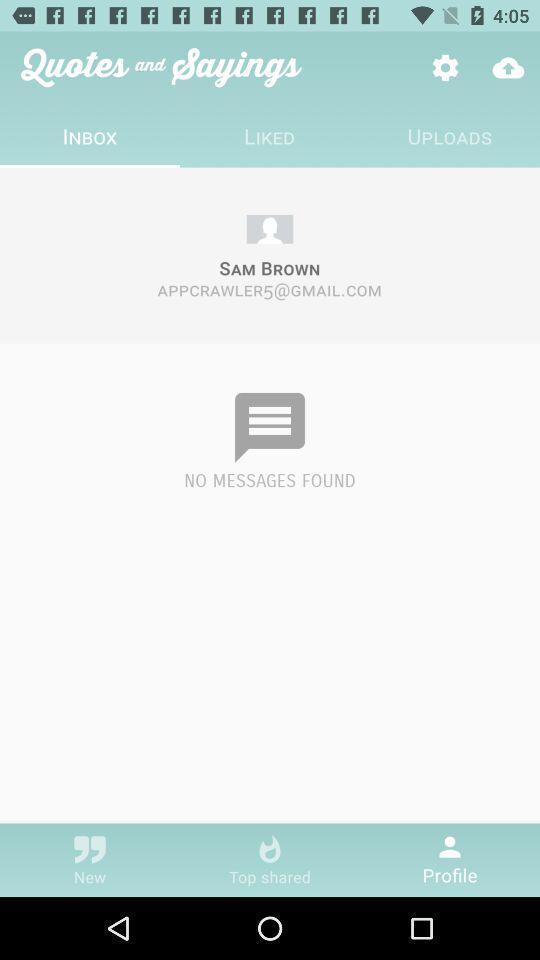Tell me what you see in this picture. Page showing information from quotes. 